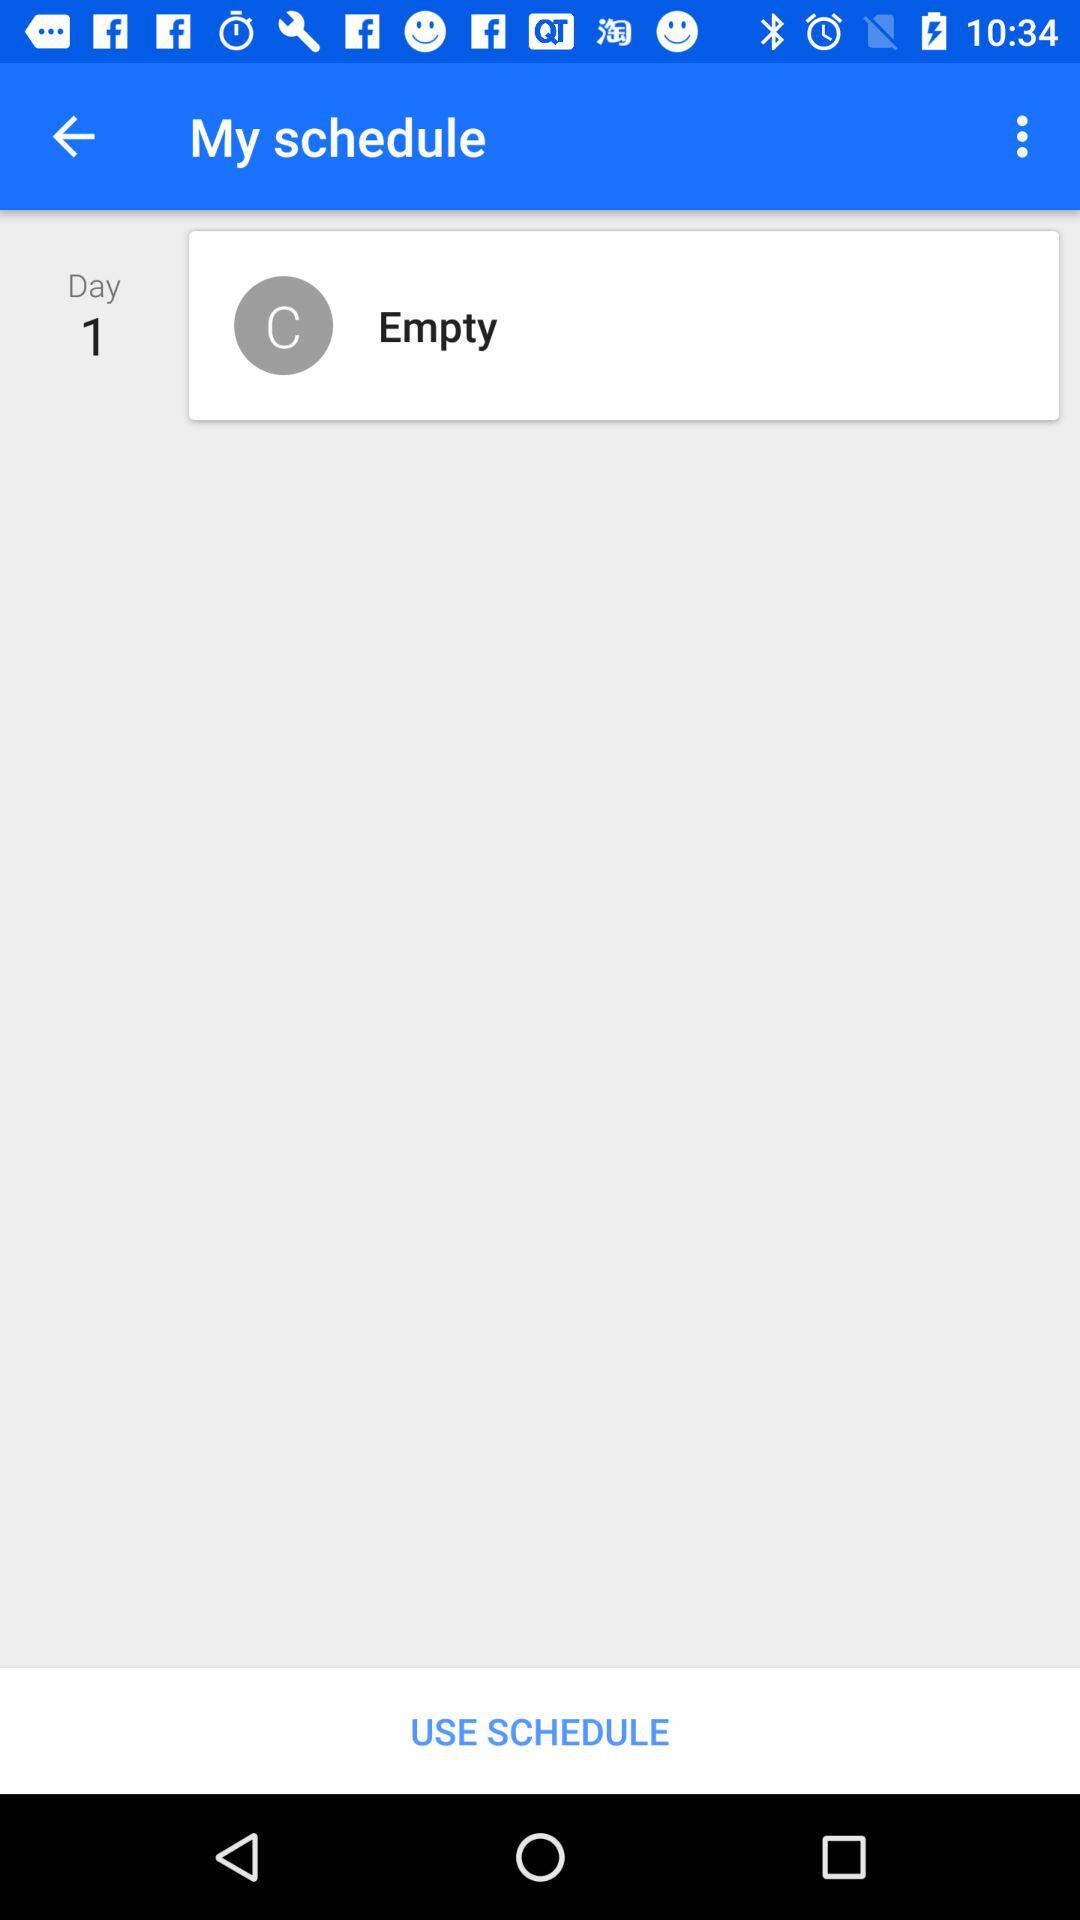What is the day 1 schedule? The day 1 schedule is empty. 